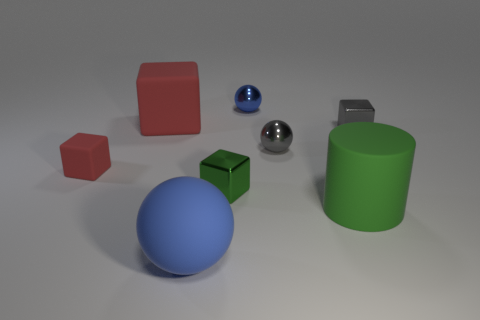Are there the same number of small green metal blocks on the left side of the big blue matte object and small cubes on the right side of the tiny red rubber block?
Provide a short and direct response. No. There is a object that is in front of the large green cylinder; does it have the same size as the red object that is in front of the large red matte block?
Keep it short and to the point. No. There is a blue object in front of the small object that is to the left of the large thing in front of the large green matte cylinder; what shape is it?
Your response must be concise. Sphere. What is the size of the other red matte object that is the same shape as the small red object?
Offer a very short reply. Large. There is a big rubber thing that is both left of the big green rubber thing and behind the big blue rubber thing; what is its color?
Make the answer very short. Red. Is the material of the gray sphere the same as the big thing that is in front of the large green cylinder?
Ensure brevity in your answer.  No. Is the number of gray spheres on the right side of the big red object less than the number of tiny blue spheres?
Keep it short and to the point. No. How many other things are there of the same shape as the small red thing?
Ensure brevity in your answer.  3. Is there anything else that is the same color as the big rubber sphere?
Keep it short and to the point. Yes. Is the color of the big cylinder the same as the tiny shiny block to the left of the small blue thing?
Your response must be concise. Yes. 